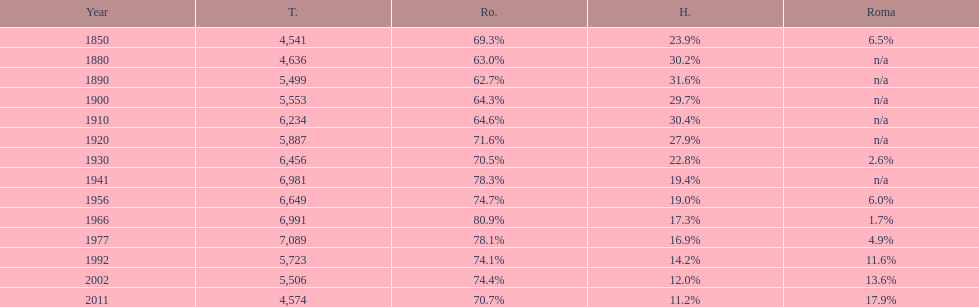I'm looking to parse the entire table for insights. Could you assist me with that? {'header': ['Year', 'T.', 'Ro.', 'H.', 'Roma'], 'rows': [['1850', '4,541', '69.3%', '23.9%', '6.5%'], ['1880', '4,636', '63.0%', '30.2%', 'n/a'], ['1890', '5,499', '62.7%', '31.6%', 'n/a'], ['1900', '5,553', '64.3%', '29.7%', 'n/a'], ['1910', '6,234', '64.6%', '30.4%', 'n/a'], ['1920', '5,887', '71.6%', '27.9%', 'n/a'], ['1930', '6,456', '70.5%', '22.8%', '2.6%'], ['1941', '6,981', '78.3%', '19.4%', 'n/a'], ['1956', '6,649', '74.7%', '19.0%', '6.0%'], ['1966', '6,991', '80.9%', '17.3%', '1.7%'], ['1977', '7,089', '78.1%', '16.9%', '4.9%'], ['1992', '5,723', '74.1%', '14.2%', '11.6%'], ['2002', '5,506', '74.4%', '12.0%', '13.6%'], ['2011', '4,574', '70.7%', '11.2%', '17.9%']]} Which year is previous to the year that had 74.1% in romanian population? 1977. 